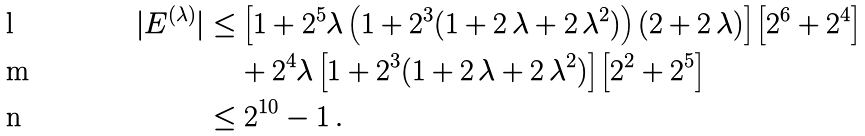Convert formula to latex. <formula><loc_0><loc_0><loc_500><loc_500>| E ^ { ( \lambda ) } | & \leq \left [ 1 + 2 ^ { 5 } \lambda \left ( 1 + 2 ^ { 3 } ( 1 + 2 \, \lambda + 2 \, \lambda ^ { 2 } ) \right ) ( 2 + 2 \, \lambda ) \right ] \left [ 2 ^ { 6 } + 2 ^ { 4 } \right ] \\ & \quad \, + 2 ^ { 4 } \lambda \left [ 1 + 2 ^ { 3 } ( 1 + 2 \, \lambda + 2 \, \lambda ^ { 2 } ) \right ] \left [ 2 ^ { 2 } + 2 ^ { 5 } \right ] \\ & \leq 2 ^ { 1 0 } - 1 \, .</formula> 